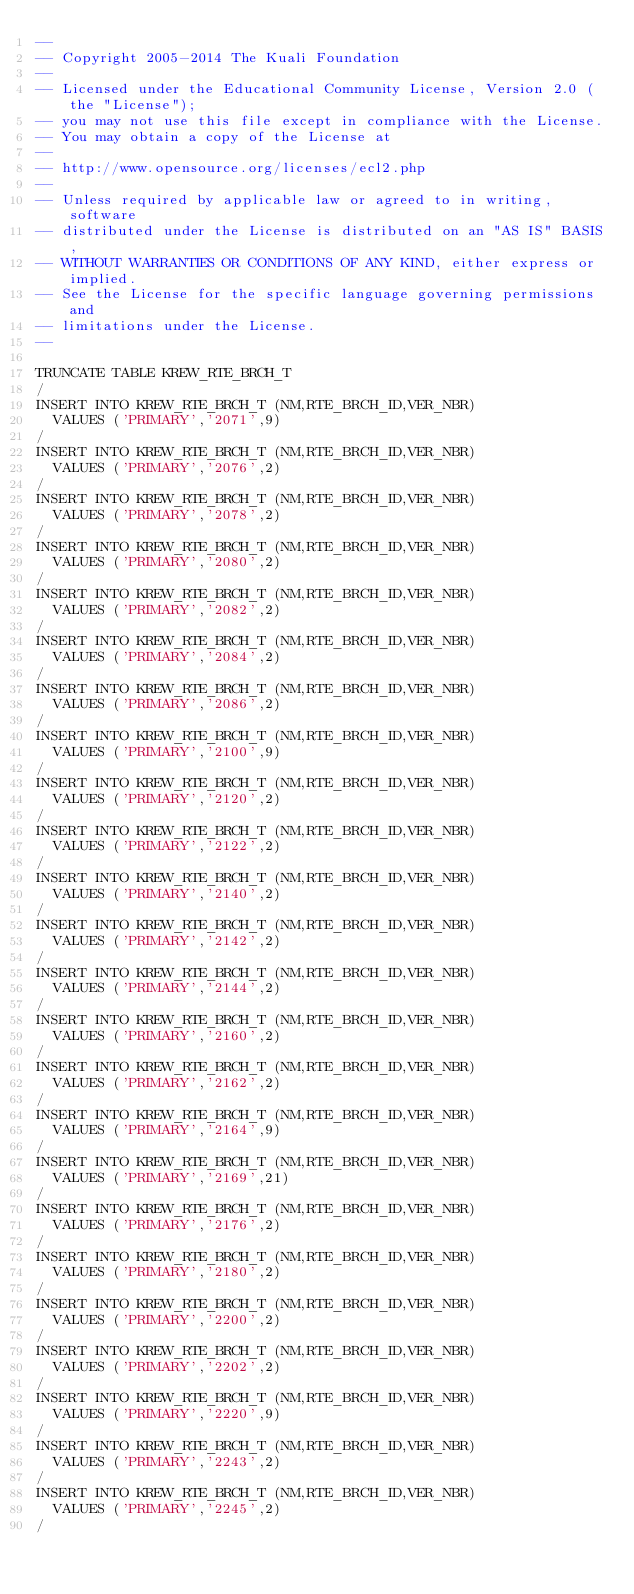<code> <loc_0><loc_0><loc_500><loc_500><_SQL_>--
-- Copyright 2005-2014 The Kuali Foundation
--
-- Licensed under the Educational Community License, Version 2.0 (the "License");
-- you may not use this file except in compliance with the License.
-- You may obtain a copy of the License at
--
-- http://www.opensource.org/licenses/ecl2.php
--
-- Unless required by applicable law or agreed to in writing, software
-- distributed under the License is distributed on an "AS IS" BASIS,
-- WITHOUT WARRANTIES OR CONDITIONS OF ANY KIND, either express or implied.
-- See the License for the specific language governing permissions and
-- limitations under the License.
--

TRUNCATE TABLE KREW_RTE_BRCH_T
/
INSERT INTO KREW_RTE_BRCH_T (NM,RTE_BRCH_ID,VER_NBR)
  VALUES ('PRIMARY','2071',9)
/
INSERT INTO KREW_RTE_BRCH_T (NM,RTE_BRCH_ID,VER_NBR)
  VALUES ('PRIMARY','2076',2)
/
INSERT INTO KREW_RTE_BRCH_T (NM,RTE_BRCH_ID,VER_NBR)
  VALUES ('PRIMARY','2078',2)
/
INSERT INTO KREW_RTE_BRCH_T (NM,RTE_BRCH_ID,VER_NBR)
  VALUES ('PRIMARY','2080',2)
/
INSERT INTO KREW_RTE_BRCH_T (NM,RTE_BRCH_ID,VER_NBR)
  VALUES ('PRIMARY','2082',2)
/
INSERT INTO KREW_RTE_BRCH_T (NM,RTE_BRCH_ID,VER_NBR)
  VALUES ('PRIMARY','2084',2)
/
INSERT INTO KREW_RTE_BRCH_T (NM,RTE_BRCH_ID,VER_NBR)
  VALUES ('PRIMARY','2086',2)
/
INSERT INTO KREW_RTE_BRCH_T (NM,RTE_BRCH_ID,VER_NBR)
  VALUES ('PRIMARY','2100',9)
/
INSERT INTO KREW_RTE_BRCH_T (NM,RTE_BRCH_ID,VER_NBR)
  VALUES ('PRIMARY','2120',2)
/
INSERT INTO KREW_RTE_BRCH_T (NM,RTE_BRCH_ID,VER_NBR)
  VALUES ('PRIMARY','2122',2)
/
INSERT INTO KREW_RTE_BRCH_T (NM,RTE_BRCH_ID,VER_NBR)
  VALUES ('PRIMARY','2140',2)
/
INSERT INTO KREW_RTE_BRCH_T (NM,RTE_BRCH_ID,VER_NBR)
  VALUES ('PRIMARY','2142',2)
/
INSERT INTO KREW_RTE_BRCH_T (NM,RTE_BRCH_ID,VER_NBR)
  VALUES ('PRIMARY','2144',2)
/
INSERT INTO KREW_RTE_BRCH_T (NM,RTE_BRCH_ID,VER_NBR)
  VALUES ('PRIMARY','2160',2)
/
INSERT INTO KREW_RTE_BRCH_T (NM,RTE_BRCH_ID,VER_NBR)
  VALUES ('PRIMARY','2162',2)
/
INSERT INTO KREW_RTE_BRCH_T (NM,RTE_BRCH_ID,VER_NBR)
  VALUES ('PRIMARY','2164',9)
/
INSERT INTO KREW_RTE_BRCH_T (NM,RTE_BRCH_ID,VER_NBR)
  VALUES ('PRIMARY','2169',21)
/
INSERT INTO KREW_RTE_BRCH_T (NM,RTE_BRCH_ID,VER_NBR)
  VALUES ('PRIMARY','2176',2)
/
INSERT INTO KREW_RTE_BRCH_T (NM,RTE_BRCH_ID,VER_NBR)
  VALUES ('PRIMARY','2180',2)
/
INSERT INTO KREW_RTE_BRCH_T (NM,RTE_BRCH_ID,VER_NBR)
  VALUES ('PRIMARY','2200',2)
/
INSERT INTO KREW_RTE_BRCH_T (NM,RTE_BRCH_ID,VER_NBR)
  VALUES ('PRIMARY','2202',2)
/
INSERT INTO KREW_RTE_BRCH_T (NM,RTE_BRCH_ID,VER_NBR)
  VALUES ('PRIMARY','2220',9)
/
INSERT INTO KREW_RTE_BRCH_T (NM,RTE_BRCH_ID,VER_NBR)
  VALUES ('PRIMARY','2243',2)
/
INSERT INTO KREW_RTE_BRCH_T (NM,RTE_BRCH_ID,VER_NBR)
  VALUES ('PRIMARY','2245',2)
/</code> 